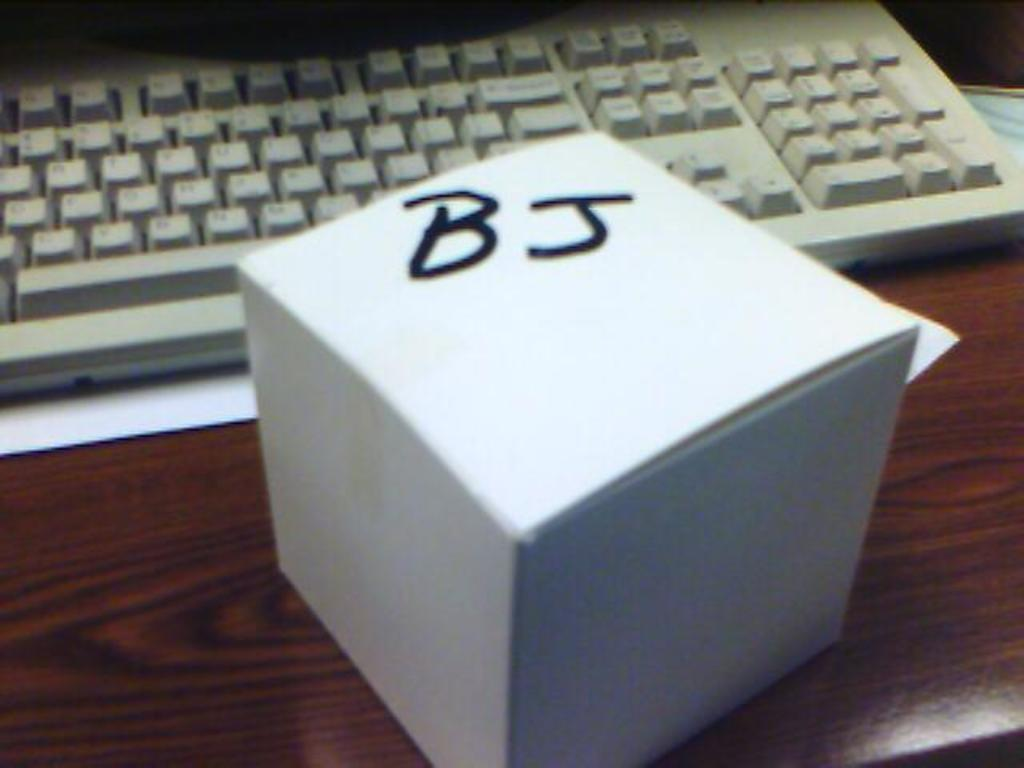<image>
Offer a succinct explanation of the picture presented. a small white box sitting in front of a keyboard labeled 'BJ' 